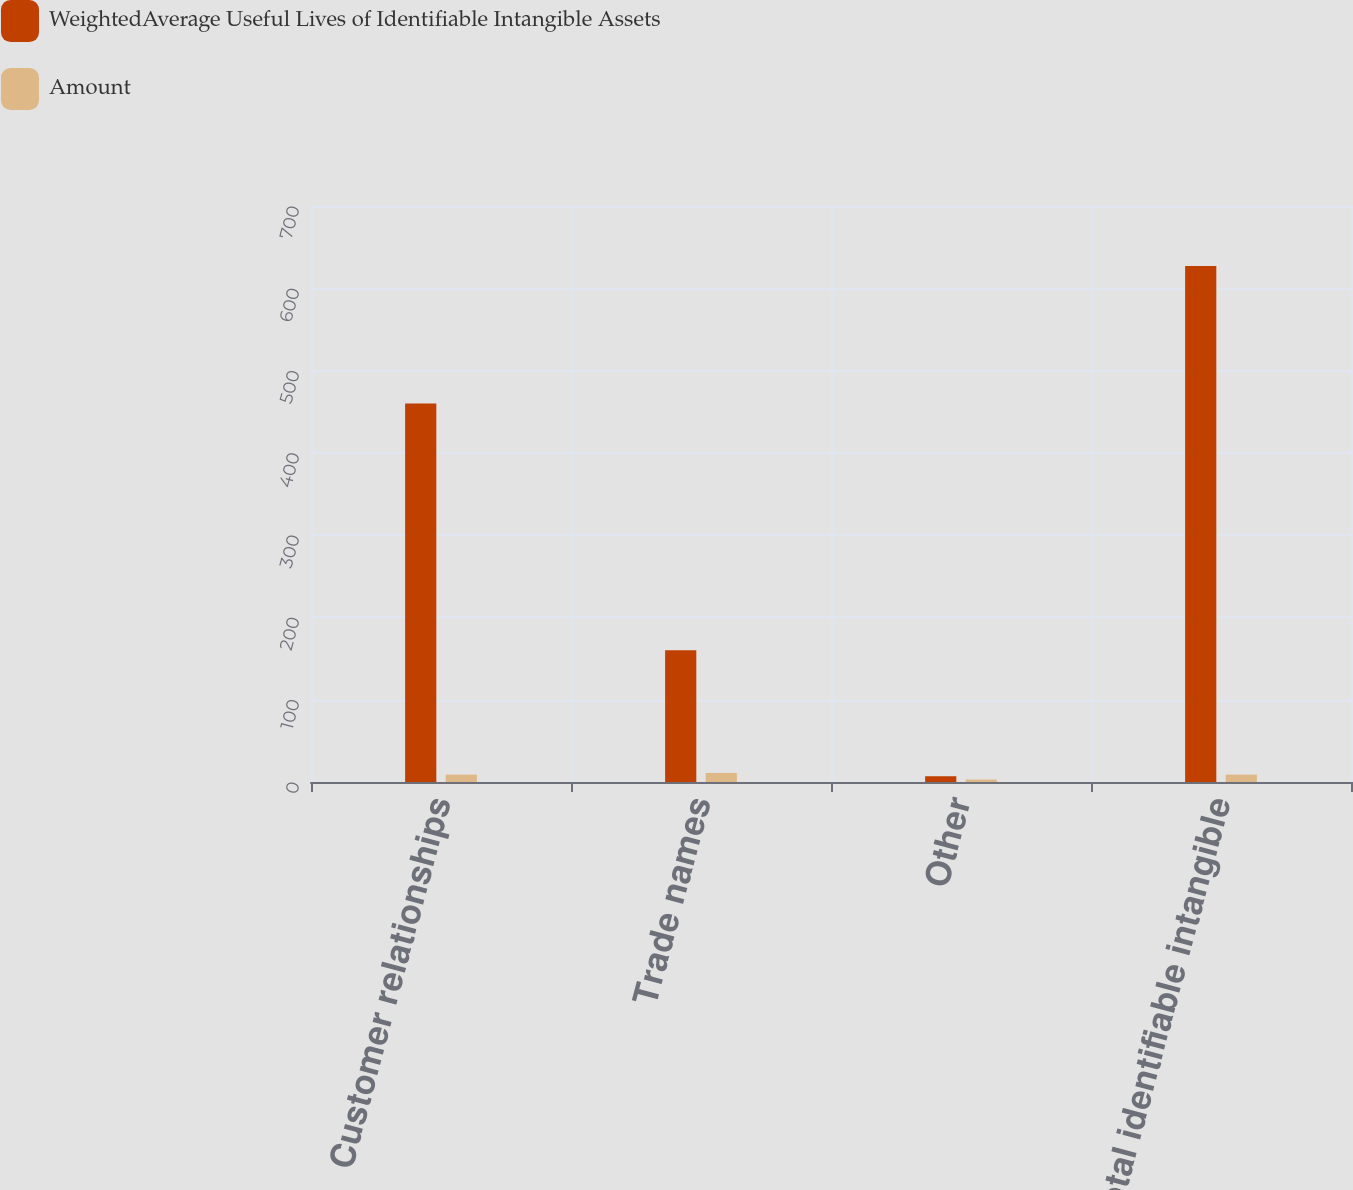Convert chart. <chart><loc_0><loc_0><loc_500><loc_500><stacked_bar_chart><ecel><fcel>Customer relationships<fcel>Trade names<fcel>Other<fcel>Total identifiable intangible<nl><fcel>WeightedAverage Useful Lives of Identifiable Intangible Assets<fcel>460<fcel>160<fcel>7<fcel>627<nl><fcel>Amount<fcel>9<fcel>11<fcel>3<fcel>9<nl></chart> 